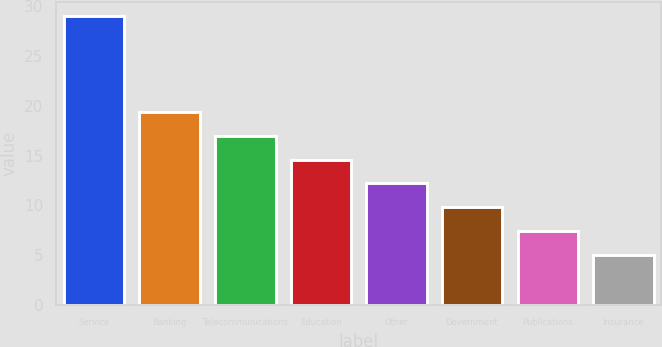Convert chart to OTSL. <chart><loc_0><loc_0><loc_500><loc_500><bar_chart><fcel>Service<fcel>Banking<fcel>Telecommunications<fcel>Education<fcel>Other<fcel>Government<fcel>Publications<fcel>Insurance<nl><fcel>29<fcel>19.4<fcel>17<fcel>14.6<fcel>12.2<fcel>9.8<fcel>7.4<fcel>5<nl></chart> 